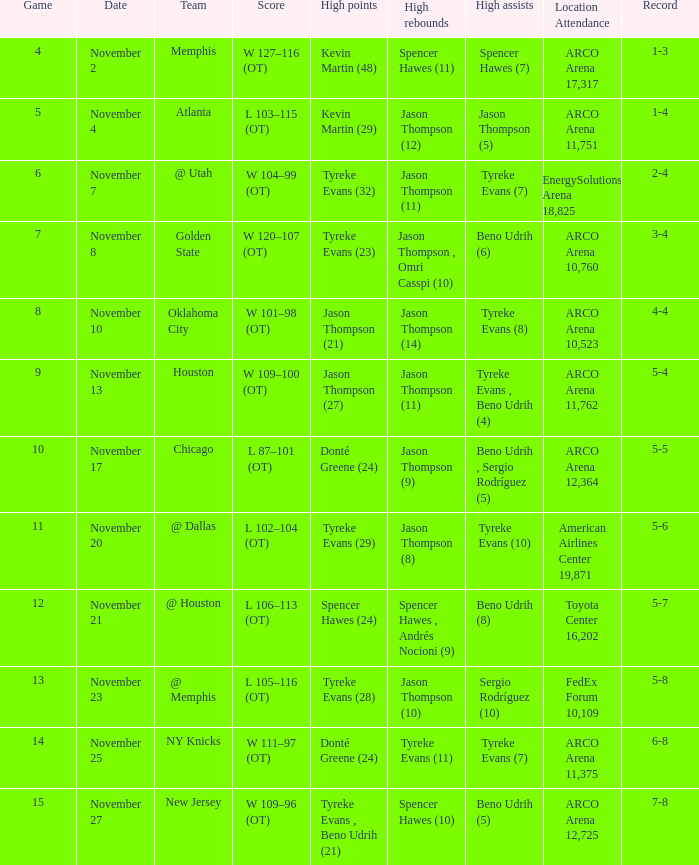If the record is 5-5, what is the game maximum? 10.0. 